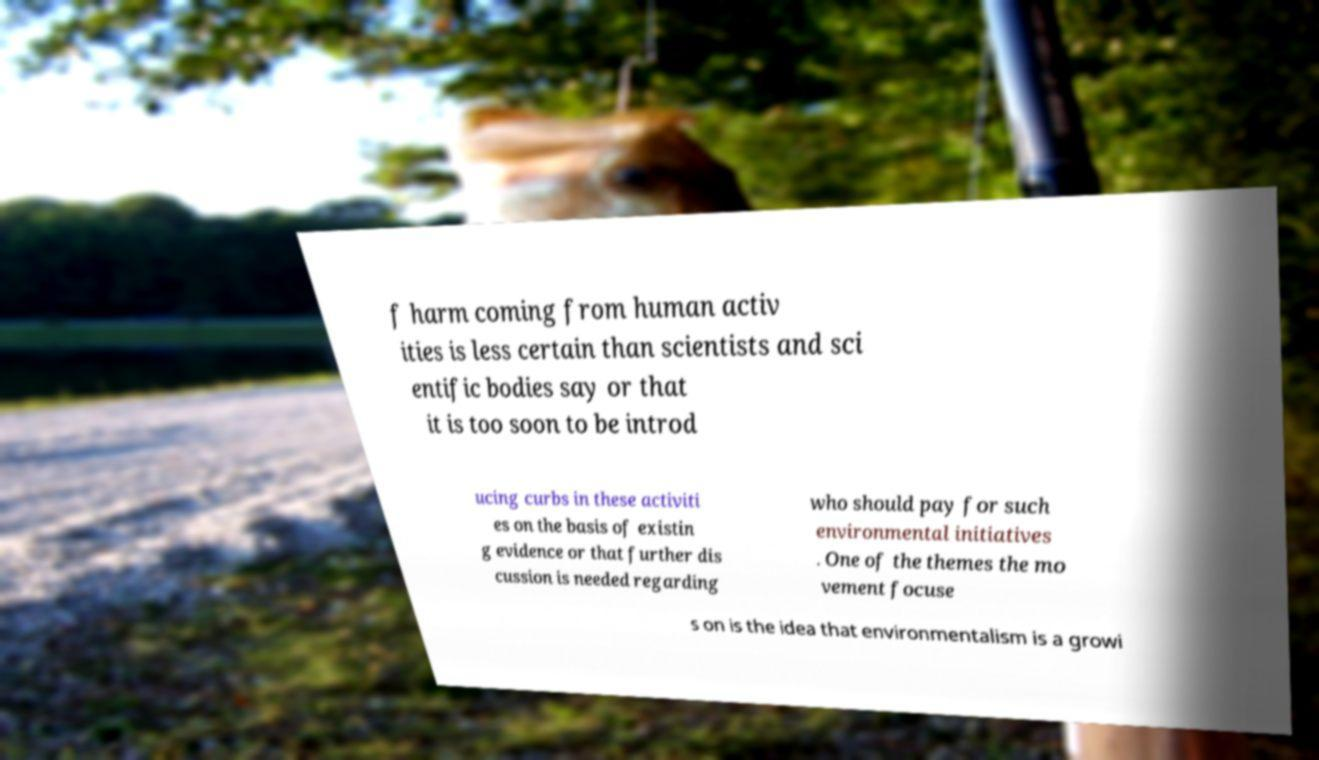Please read and relay the text visible in this image. What does it say? f harm coming from human activ ities is less certain than scientists and sci entific bodies say or that it is too soon to be introd ucing curbs in these activiti es on the basis of existin g evidence or that further dis cussion is needed regarding who should pay for such environmental initiatives . One of the themes the mo vement focuse s on is the idea that environmentalism is a growi 